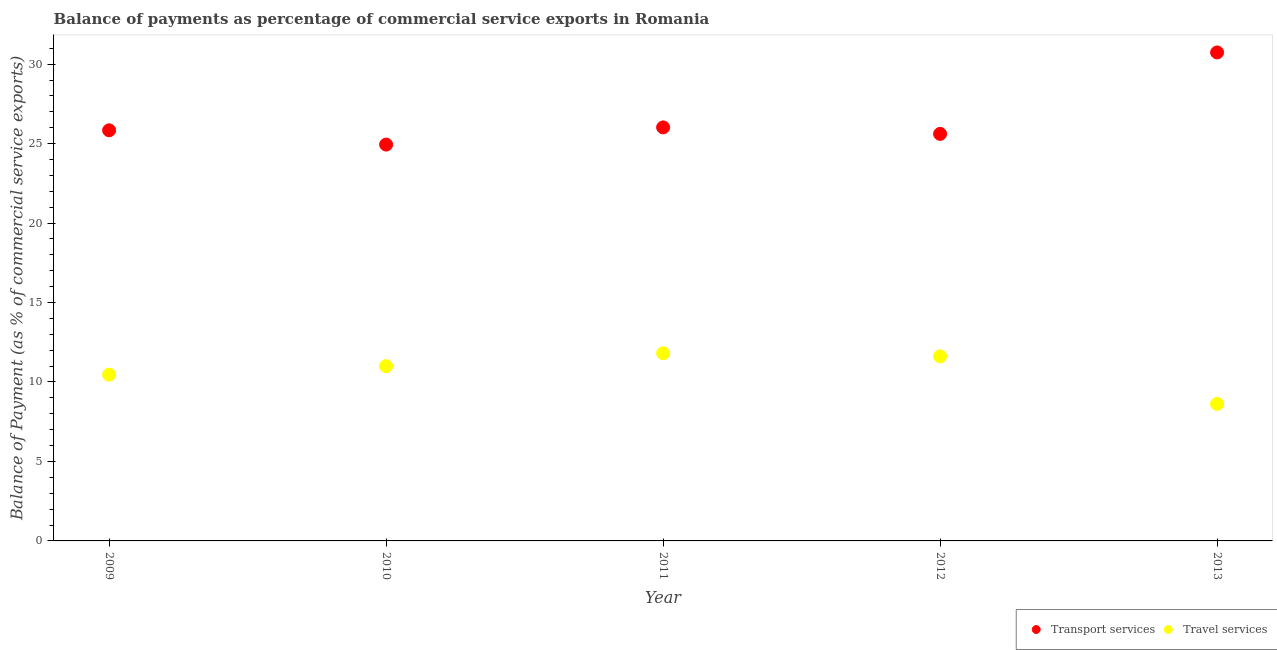How many different coloured dotlines are there?
Offer a terse response. 2. What is the balance of payments of travel services in 2009?
Offer a very short reply. 10.46. Across all years, what is the maximum balance of payments of transport services?
Your response must be concise. 30.73. Across all years, what is the minimum balance of payments of travel services?
Offer a terse response. 8.62. In which year was the balance of payments of transport services maximum?
Provide a succinct answer. 2013. What is the total balance of payments of travel services in the graph?
Your answer should be very brief. 53.5. What is the difference between the balance of payments of transport services in 2009 and that in 2010?
Your answer should be compact. 0.9. What is the difference between the balance of payments of transport services in 2011 and the balance of payments of travel services in 2009?
Your response must be concise. 15.56. What is the average balance of payments of travel services per year?
Provide a succinct answer. 10.7. In the year 2010, what is the difference between the balance of payments of transport services and balance of payments of travel services?
Keep it short and to the point. 13.94. In how many years, is the balance of payments of transport services greater than 20 %?
Keep it short and to the point. 5. What is the ratio of the balance of payments of transport services in 2012 to that in 2013?
Ensure brevity in your answer.  0.83. What is the difference between the highest and the second highest balance of payments of travel services?
Make the answer very short. 0.19. What is the difference between the highest and the lowest balance of payments of travel services?
Your answer should be compact. 3.19. Is the balance of payments of travel services strictly less than the balance of payments of transport services over the years?
Your answer should be very brief. Yes. Are the values on the major ticks of Y-axis written in scientific E-notation?
Make the answer very short. No. Does the graph contain grids?
Ensure brevity in your answer.  No. What is the title of the graph?
Your response must be concise. Balance of payments as percentage of commercial service exports in Romania. Does "Official creditors" appear as one of the legend labels in the graph?
Give a very brief answer. No. What is the label or title of the Y-axis?
Provide a short and direct response. Balance of Payment (as % of commercial service exports). What is the Balance of Payment (as % of commercial service exports) in Transport services in 2009?
Provide a succinct answer. 25.83. What is the Balance of Payment (as % of commercial service exports) of Travel services in 2009?
Keep it short and to the point. 10.46. What is the Balance of Payment (as % of commercial service exports) in Transport services in 2010?
Make the answer very short. 24.94. What is the Balance of Payment (as % of commercial service exports) of Travel services in 2010?
Give a very brief answer. 11. What is the Balance of Payment (as % of commercial service exports) of Transport services in 2011?
Offer a terse response. 26.02. What is the Balance of Payment (as % of commercial service exports) of Travel services in 2011?
Your answer should be compact. 11.81. What is the Balance of Payment (as % of commercial service exports) in Transport services in 2012?
Your answer should be compact. 25.61. What is the Balance of Payment (as % of commercial service exports) in Travel services in 2012?
Give a very brief answer. 11.61. What is the Balance of Payment (as % of commercial service exports) in Transport services in 2013?
Offer a terse response. 30.73. What is the Balance of Payment (as % of commercial service exports) of Travel services in 2013?
Offer a terse response. 8.62. Across all years, what is the maximum Balance of Payment (as % of commercial service exports) of Transport services?
Your answer should be very brief. 30.73. Across all years, what is the maximum Balance of Payment (as % of commercial service exports) in Travel services?
Provide a short and direct response. 11.81. Across all years, what is the minimum Balance of Payment (as % of commercial service exports) of Transport services?
Provide a succinct answer. 24.94. Across all years, what is the minimum Balance of Payment (as % of commercial service exports) in Travel services?
Make the answer very short. 8.62. What is the total Balance of Payment (as % of commercial service exports) of Transport services in the graph?
Keep it short and to the point. 133.13. What is the total Balance of Payment (as % of commercial service exports) of Travel services in the graph?
Keep it short and to the point. 53.5. What is the difference between the Balance of Payment (as % of commercial service exports) in Transport services in 2009 and that in 2010?
Provide a short and direct response. 0.9. What is the difference between the Balance of Payment (as % of commercial service exports) in Travel services in 2009 and that in 2010?
Keep it short and to the point. -0.54. What is the difference between the Balance of Payment (as % of commercial service exports) of Transport services in 2009 and that in 2011?
Your answer should be very brief. -0.18. What is the difference between the Balance of Payment (as % of commercial service exports) of Travel services in 2009 and that in 2011?
Ensure brevity in your answer.  -1.35. What is the difference between the Balance of Payment (as % of commercial service exports) in Transport services in 2009 and that in 2012?
Provide a short and direct response. 0.22. What is the difference between the Balance of Payment (as % of commercial service exports) in Travel services in 2009 and that in 2012?
Keep it short and to the point. -1.15. What is the difference between the Balance of Payment (as % of commercial service exports) of Transport services in 2009 and that in 2013?
Ensure brevity in your answer.  -4.9. What is the difference between the Balance of Payment (as % of commercial service exports) in Travel services in 2009 and that in 2013?
Your answer should be very brief. 1.84. What is the difference between the Balance of Payment (as % of commercial service exports) in Transport services in 2010 and that in 2011?
Make the answer very short. -1.08. What is the difference between the Balance of Payment (as % of commercial service exports) of Travel services in 2010 and that in 2011?
Your answer should be compact. -0.81. What is the difference between the Balance of Payment (as % of commercial service exports) in Transport services in 2010 and that in 2012?
Keep it short and to the point. -0.67. What is the difference between the Balance of Payment (as % of commercial service exports) of Travel services in 2010 and that in 2012?
Keep it short and to the point. -0.62. What is the difference between the Balance of Payment (as % of commercial service exports) of Transport services in 2010 and that in 2013?
Keep it short and to the point. -5.8. What is the difference between the Balance of Payment (as % of commercial service exports) of Travel services in 2010 and that in 2013?
Make the answer very short. 2.38. What is the difference between the Balance of Payment (as % of commercial service exports) in Transport services in 2011 and that in 2012?
Ensure brevity in your answer.  0.41. What is the difference between the Balance of Payment (as % of commercial service exports) in Travel services in 2011 and that in 2012?
Give a very brief answer. 0.19. What is the difference between the Balance of Payment (as % of commercial service exports) of Transport services in 2011 and that in 2013?
Make the answer very short. -4.72. What is the difference between the Balance of Payment (as % of commercial service exports) in Travel services in 2011 and that in 2013?
Provide a succinct answer. 3.19. What is the difference between the Balance of Payment (as % of commercial service exports) in Transport services in 2012 and that in 2013?
Keep it short and to the point. -5.12. What is the difference between the Balance of Payment (as % of commercial service exports) of Travel services in 2012 and that in 2013?
Provide a succinct answer. 2.99. What is the difference between the Balance of Payment (as % of commercial service exports) in Transport services in 2009 and the Balance of Payment (as % of commercial service exports) in Travel services in 2010?
Your answer should be very brief. 14.84. What is the difference between the Balance of Payment (as % of commercial service exports) of Transport services in 2009 and the Balance of Payment (as % of commercial service exports) of Travel services in 2011?
Your answer should be compact. 14.03. What is the difference between the Balance of Payment (as % of commercial service exports) in Transport services in 2009 and the Balance of Payment (as % of commercial service exports) in Travel services in 2012?
Provide a short and direct response. 14.22. What is the difference between the Balance of Payment (as % of commercial service exports) in Transport services in 2009 and the Balance of Payment (as % of commercial service exports) in Travel services in 2013?
Keep it short and to the point. 17.21. What is the difference between the Balance of Payment (as % of commercial service exports) in Transport services in 2010 and the Balance of Payment (as % of commercial service exports) in Travel services in 2011?
Your answer should be very brief. 13.13. What is the difference between the Balance of Payment (as % of commercial service exports) of Transport services in 2010 and the Balance of Payment (as % of commercial service exports) of Travel services in 2012?
Your response must be concise. 13.32. What is the difference between the Balance of Payment (as % of commercial service exports) of Transport services in 2010 and the Balance of Payment (as % of commercial service exports) of Travel services in 2013?
Provide a short and direct response. 16.32. What is the difference between the Balance of Payment (as % of commercial service exports) of Transport services in 2011 and the Balance of Payment (as % of commercial service exports) of Travel services in 2012?
Offer a terse response. 14.4. What is the difference between the Balance of Payment (as % of commercial service exports) in Transport services in 2011 and the Balance of Payment (as % of commercial service exports) in Travel services in 2013?
Give a very brief answer. 17.4. What is the difference between the Balance of Payment (as % of commercial service exports) of Transport services in 2012 and the Balance of Payment (as % of commercial service exports) of Travel services in 2013?
Offer a very short reply. 16.99. What is the average Balance of Payment (as % of commercial service exports) of Transport services per year?
Make the answer very short. 26.63. What is the average Balance of Payment (as % of commercial service exports) of Travel services per year?
Offer a very short reply. 10.7. In the year 2009, what is the difference between the Balance of Payment (as % of commercial service exports) of Transport services and Balance of Payment (as % of commercial service exports) of Travel services?
Offer a very short reply. 15.37. In the year 2010, what is the difference between the Balance of Payment (as % of commercial service exports) in Transport services and Balance of Payment (as % of commercial service exports) in Travel services?
Keep it short and to the point. 13.94. In the year 2011, what is the difference between the Balance of Payment (as % of commercial service exports) of Transport services and Balance of Payment (as % of commercial service exports) of Travel services?
Make the answer very short. 14.21. In the year 2012, what is the difference between the Balance of Payment (as % of commercial service exports) in Transport services and Balance of Payment (as % of commercial service exports) in Travel services?
Keep it short and to the point. 14. In the year 2013, what is the difference between the Balance of Payment (as % of commercial service exports) in Transport services and Balance of Payment (as % of commercial service exports) in Travel services?
Your answer should be compact. 22.11. What is the ratio of the Balance of Payment (as % of commercial service exports) in Transport services in 2009 to that in 2010?
Keep it short and to the point. 1.04. What is the ratio of the Balance of Payment (as % of commercial service exports) of Travel services in 2009 to that in 2010?
Your answer should be very brief. 0.95. What is the ratio of the Balance of Payment (as % of commercial service exports) of Transport services in 2009 to that in 2011?
Offer a terse response. 0.99. What is the ratio of the Balance of Payment (as % of commercial service exports) in Travel services in 2009 to that in 2011?
Your response must be concise. 0.89. What is the ratio of the Balance of Payment (as % of commercial service exports) of Transport services in 2009 to that in 2012?
Give a very brief answer. 1.01. What is the ratio of the Balance of Payment (as % of commercial service exports) of Travel services in 2009 to that in 2012?
Give a very brief answer. 0.9. What is the ratio of the Balance of Payment (as % of commercial service exports) in Transport services in 2009 to that in 2013?
Offer a terse response. 0.84. What is the ratio of the Balance of Payment (as % of commercial service exports) of Travel services in 2009 to that in 2013?
Keep it short and to the point. 1.21. What is the ratio of the Balance of Payment (as % of commercial service exports) in Transport services in 2010 to that in 2011?
Your answer should be compact. 0.96. What is the ratio of the Balance of Payment (as % of commercial service exports) of Travel services in 2010 to that in 2011?
Offer a terse response. 0.93. What is the ratio of the Balance of Payment (as % of commercial service exports) in Transport services in 2010 to that in 2012?
Offer a terse response. 0.97. What is the ratio of the Balance of Payment (as % of commercial service exports) of Travel services in 2010 to that in 2012?
Give a very brief answer. 0.95. What is the ratio of the Balance of Payment (as % of commercial service exports) in Transport services in 2010 to that in 2013?
Make the answer very short. 0.81. What is the ratio of the Balance of Payment (as % of commercial service exports) in Travel services in 2010 to that in 2013?
Provide a succinct answer. 1.28. What is the ratio of the Balance of Payment (as % of commercial service exports) in Transport services in 2011 to that in 2012?
Make the answer very short. 1.02. What is the ratio of the Balance of Payment (as % of commercial service exports) of Travel services in 2011 to that in 2012?
Give a very brief answer. 1.02. What is the ratio of the Balance of Payment (as % of commercial service exports) of Transport services in 2011 to that in 2013?
Ensure brevity in your answer.  0.85. What is the ratio of the Balance of Payment (as % of commercial service exports) of Travel services in 2011 to that in 2013?
Give a very brief answer. 1.37. What is the ratio of the Balance of Payment (as % of commercial service exports) in Travel services in 2012 to that in 2013?
Provide a succinct answer. 1.35. What is the difference between the highest and the second highest Balance of Payment (as % of commercial service exports) of Transport services?
Offer a terse response. 4.72. What is the difference between the highest and the second highest Balance of Payment (as % of commercial service exports) of Travel services?
Offer a terse response. 0.19. What is the difference between the highest and the lowest Balance of Payment (as % of commercial service exports) of Transport services?
Give a very brief answer. 5.8. What is the difference between the highest and the lowest Balance of Payment (as % of commercial service exports) in Travel services?
Provide a short and direct response. 3.19. 